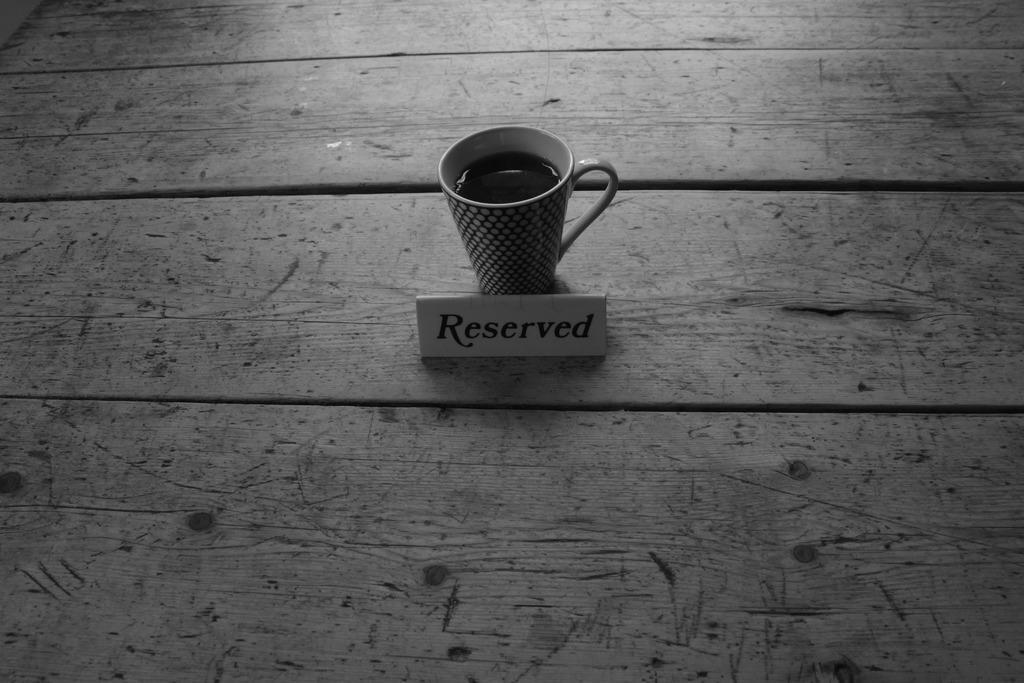How would you summarize this image in a sentence or two? In this image, we can see a coffee with cup is placed on the wooden surface. Here we can see a name board. 